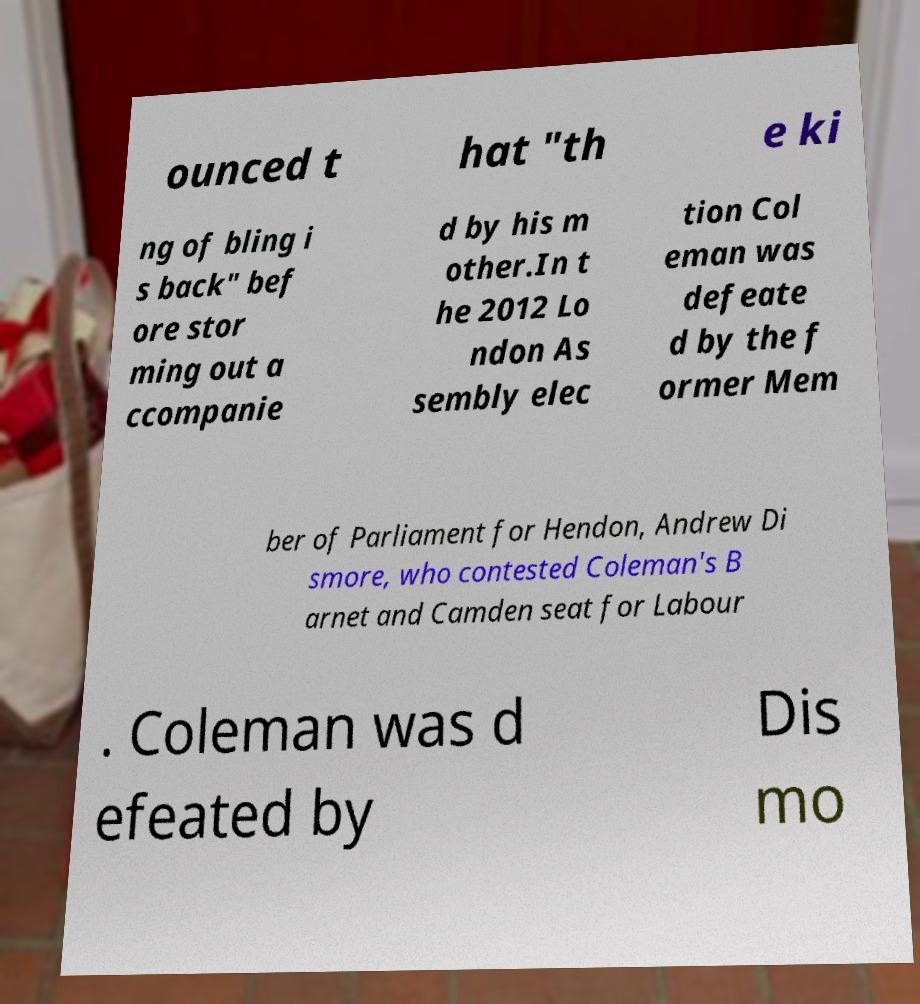Could you assist in decoding the text presented in this image and type it out clearly? ounced t hat "th e ki ng of bling i s back" bef ore stor ming out a ccompanie d by his m other.In t he 2012 Lo ndon As sembly elec tion Col eman was defeate d by the f ormer Mem ber of Parliament for Hendon, Andrew Di smore, who contested Coleman's B arnet and Camden seat for Labour . Coleman was d efeated by Dis mo 